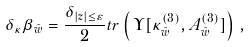Convert formula to latex. <formula><loc_0><loc_0><loc_500><loc_500>\delta _ { \kappa } \beta _ { \bar { w } } = \frac { \delta _ { | z | \leq \varepsilon } } { 2 } t r \left ( \, \Upsilon [ \kappa ^ { ( 3 ) } _ { \bar { w } } , A ^ { ( 3 ) } _ { \bar { w } } ] \right ) \, ,</formula> 